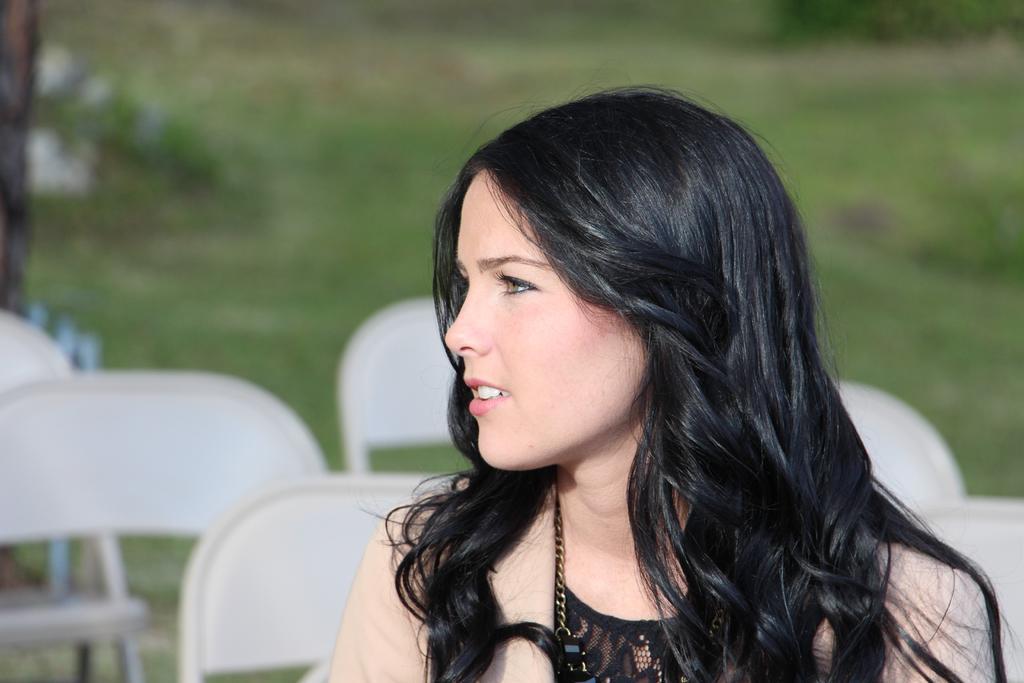Could you give a brief overview of what you see in this image? In this image we can see a woman and there are some chairs and in the background the image is blurred. 